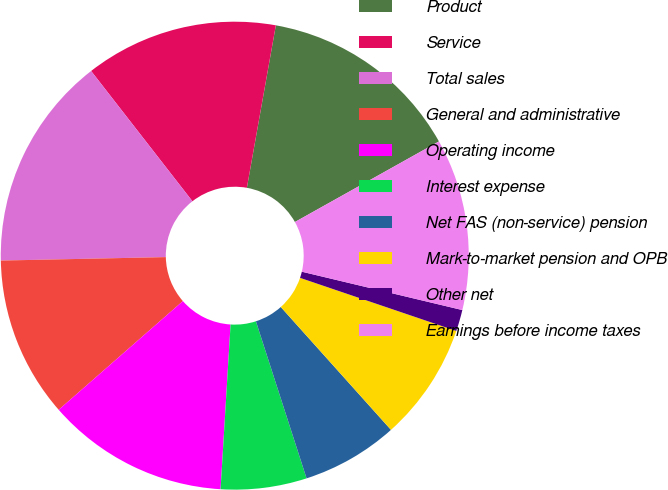Convert chart to OTSL. <chart><loc_0><loc_0><loc_500><loc_500><pie_chart><fcel>Product<fcel>Service<fcel>Total sales<fcel>General and administrative<fcel>Operating income<fcel>Interest expense<fcel>Net FAS (non-service) pension<fcel>Mark-to-market pension and OPB<fcel>Other net<fcel>Earnings before income taxes<nl><fcel>14.07%<fcel>13.33%<fcel>14.81%<fcel>11.11%<fcel>12.59%<fcel>5.93%<fcel>6.67%<fcel>8.15%<fcel>1.48%<fcel>11.85%<nl></chart> 